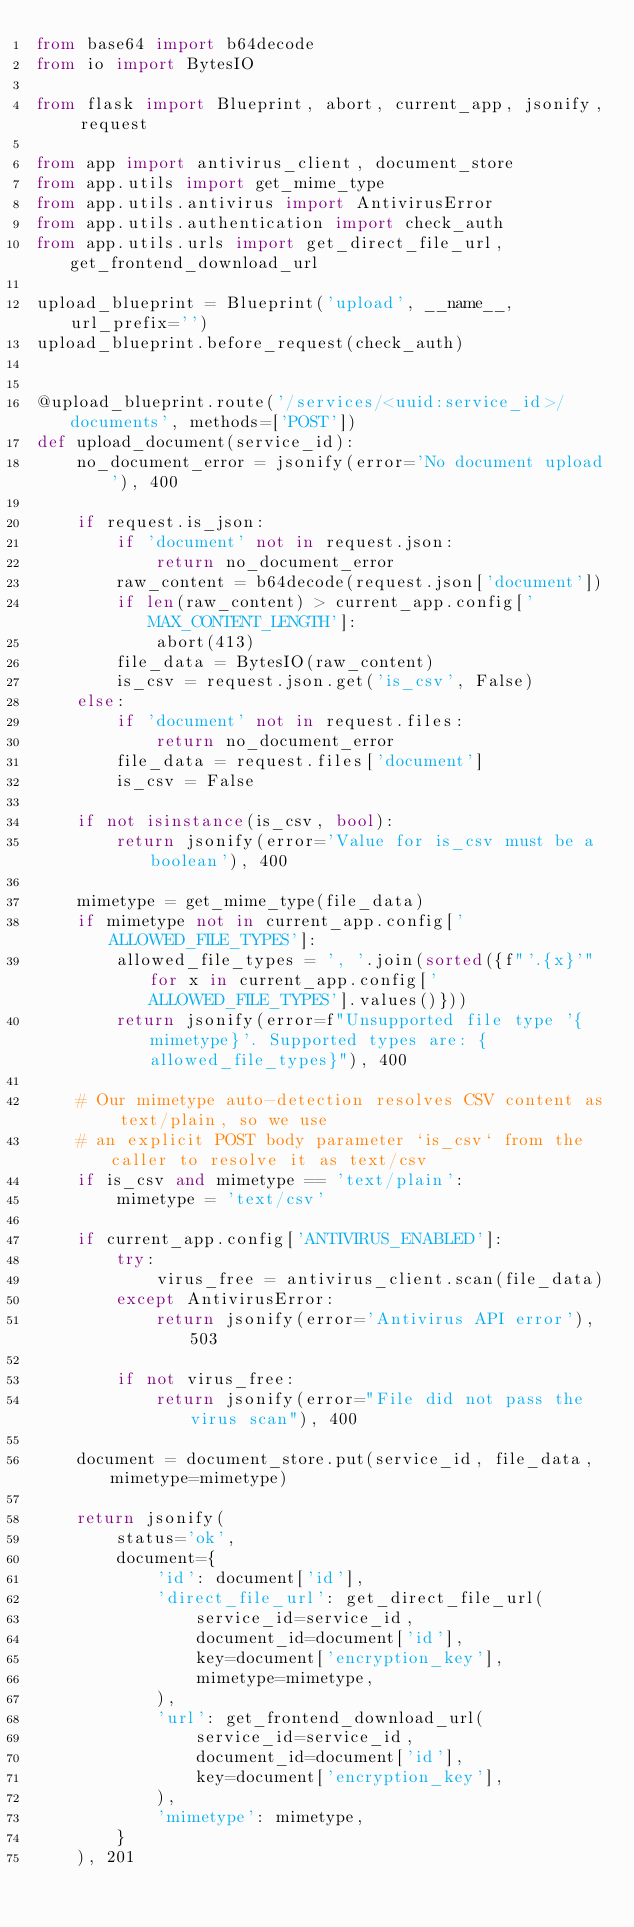Convert code to text. <code><loc_0><loc_0><loc_500><loc_500><_Python_>from base64 import b64decode
from io import BytesIO

from flask import Blueprint, abort, current_app, jsonify, request

from app import antivirus_client, document_store
from app.utils import get_mime_type
from app.utils.antivirus import AntivirusError
from app.utils.authentication import check_auth
from app.utils.urls import get_direct_file_url, get_frontend_download_url

upload_blueprint = Blueprint('upload', __name__, url_prefix='')
upload_blueprint.before_request(check_auth)


@upload_blueprint.route('/services/<uuid:service_id>/documents', methods=['POST'])
def upload_document(service_id):
    no_document_error = jsonify(error='No document upload'), 400

    if request.is_json:
        if 'document' not in request.json:
            return no_document_error
        raw_content = b64decode(request.json['document'])
        if len(raw_content) > current_app.config['MAX_CONTENT_LENGTH']:
            abort(413)
        file_data = BytesIO(raw_content)
        is_csv = request.json.get('is_csv', False)
    else:
        if 'document' not in request.files:
            return no_document_error
        file_data = request.files['document']
        is_csv = False

    if not isinstance(is_csv, bool):
        return jsonify(error='Value for is_csv must be a boolean'), 400

    mimetype = get_mime_type(file_data)
    if mimetype not in current_app.config['ALLOWED_FILE_TYPES']:
        allowed_file_types = ', '.join(sorted({f"'.{x}'" for x in current_app.config['ALLOWED_FILE_TYPES'].values()}))
        return jsonify(error=f"Unsupported file type '{mimetype}'. Supported types are: {allowed_file_types}"), 400

    # Our mimetype auto-detection resolves CSV content as text/plain, so we use
    # an explicit POST body parameter `is_csv` from the caller to resolve it as text/csv
    if is_csv and mimetype == 'text/plain':
        mimetype = 'text/csv'

    if current_app.config['ANTIVIRUS_ENABLED']:
        try:
            virus_free = antivirus_client.scan(file_data)
        except AntivirusError:
            return jsonify(error='Antivirus API error'), 503

        if not virus_free:
            return jsonify(error="File did not pass the virus scan"), 400

    document = document_store.put(service_id, file_data, mimetype=mimetype)

    return jsonify(
        status='ok',
        document={
            'id': document['id'],
            'direct_file_url': get_direct_file_url(
                service_id=service_id,
                document_id=document['id'],
                key=document['encryption_key'],
                mimetype=mimetype,
            ),
            'url': get_frontend_download_url(
                service_id=service_id,
                document_id=document['id'],
                key=document['encryption_key'],
            ),
            'mimetype': mimetype,
        }
    ), 201
</code> 